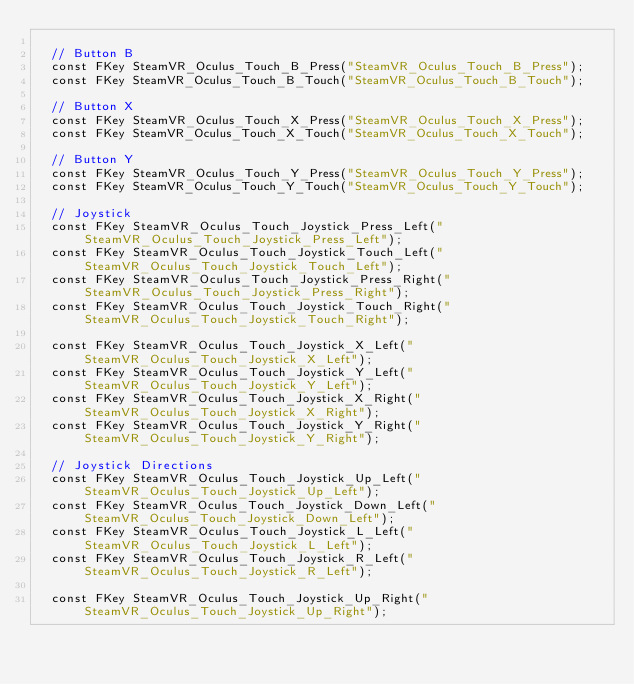Convert code to text. <code><loc_0><loc_0><loc_500><loc_500><_C_>
	// Button B
	const FKey SteamVR_Oculus_Touch_B_Press("SteamVR_Oculus_Touch_B_Press");
	const FKey SteamVR_Oculus_Touch_B_Touch("SteamVR_Oculus_Touch_B_Touch");

	// Button X
	const FKey SteamVR_Oculus_Touch_X_Press("SteamVR_Oculus_Touch_X_Press");
	const FKey SteamVR_Oculus_Touch_X_Touch("SteamVR_Oculus_Touch_X_Touch");

	// Button Y
	const FKey SteamVR_Oculus_Touch_Y_Press("SteamVR_Oculus_Touch_Y_Press");
	const FKey SteamVR_Oculus_Touch_Y_Touch("SteamVR_Oculus_Touch_Y_Touch");

	// Joystick
	const FKey SteamVR_Oculus_Touch_Joystick_Press_Left("SteamVR_Oculus_Touch_Joystick_Press_Left");
	const FKey SteamVR_Oculus_Touch_Joystick_Touch_Left("SteamVR_Oculus_Touch_Joystick_Touch_Left");
	const FKey SteamVR_Oculus_Touch_Joystick_Press_Right("SteamVR_Oculus_Touch_Joystick_Press_Right");
	const FKey SteamVR_Oculus_Touch_Joystick_Touch_Right("SteamVR_Oculus_Touch_Joystick_Touch_Right");

	const FKey SteamVR_Oculus_Touch_Joystick_X_Left("SteamVR_Oculus_Touch_Joystick_X_Left");
	const FKey SteamVR_Oculus_Touch_Joystick_Y_Left("SteamVR_Oculus_Touch_Joystick_Y_Left");
	const FKey SteamVR_Oculus_Touch_Joystick_X_Right("SteamVR_Oculus_Touch_Joystick_X_Right");
	const FKey SteamVR_Oculus_Touch_Joystick_Y_Right("SteamVR_Oculus_Touch_Joystick_Y_Right");

	// Joystick Directions
	const FKey SteamVR_Oculus_Touch_Joystick_Up_Left("SteamVR_Oculus_Touch_Joystick_Up_Left");
	const FKey SteamVR_Oculus_Touch_Joystick_Down_Left("SteamVR_Oculus_Touch_Joystick_Down_Left");
	const FKey SteamVR_Oculus_Touch_Joystick_L_Left("SteamVR_Oculus_Touch_Joystick_L_Left");
	const FKey SteamVR_Oculus_Touch_Joystick_R_Left("SteamVR_Oculus_Touch_Joystick_R_Left");

	const FKey SteamVR_Oculus_Touch_Joystick_Up_Right("SteamVR_Oculus_Touch_Joystick_Up_Right");</code> 